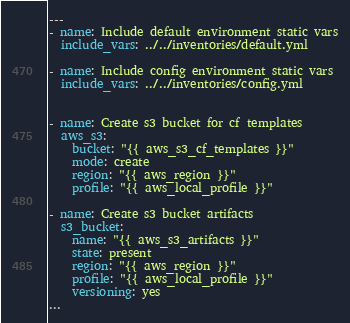<code> <loc_0><loc_0><loc_500><loc_500><_YAML_>---
- name: Include default environment static vars
  include_vars: ../../inventories/default.yml

- name: Include config environment static vars
  include_vars: ../../inventories/config.yml


- name: Create s3 bucket for cf templates
  aws_s3:
    bucket: "{{ aws_s3_cf_templates }}"
    mode: create
    region: "{{ aws_region }}"
    profile: "{{ aws_local_profile }}"

- name: Create s3 bucket artifacts
  s3_bucket:
    name: "{{ aws_s3_artifacts }}"
    state: present
    region: "{{ aws_region }}"
    profile: "{{ aws_local_profile }}"
    versioning: yes
...</code> 